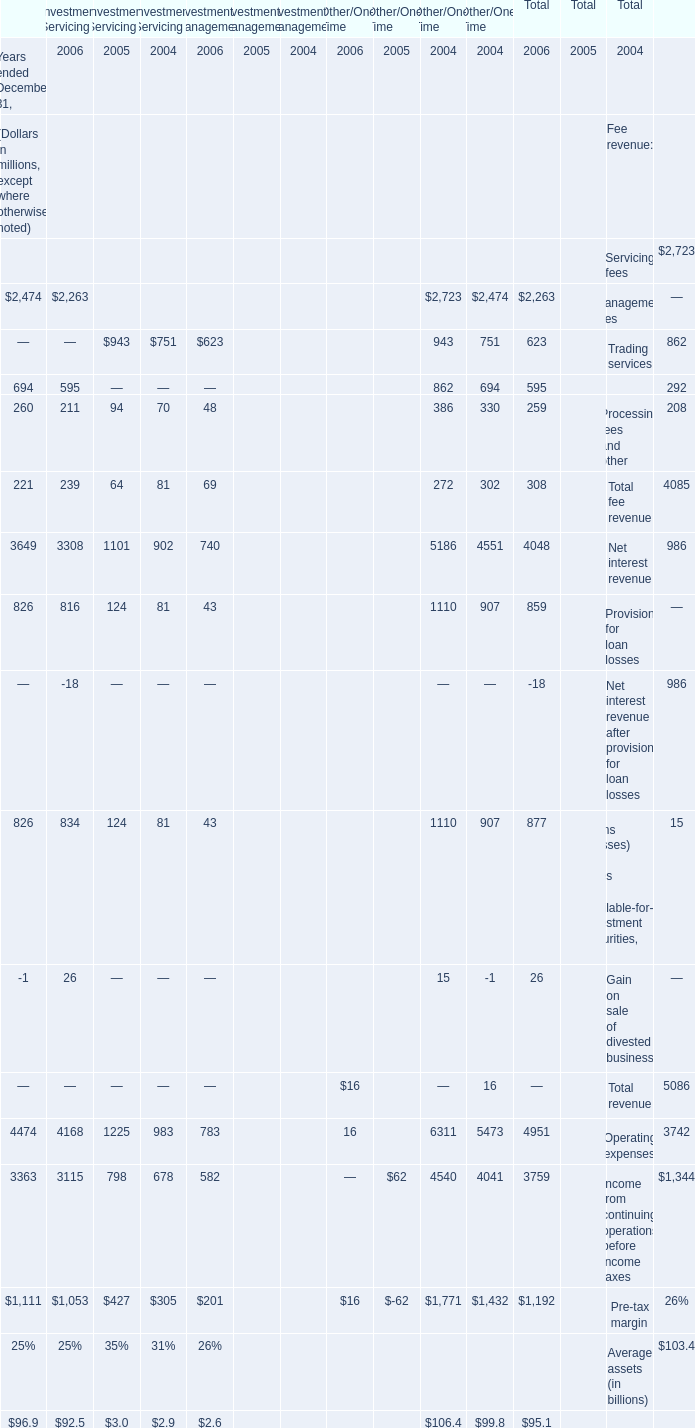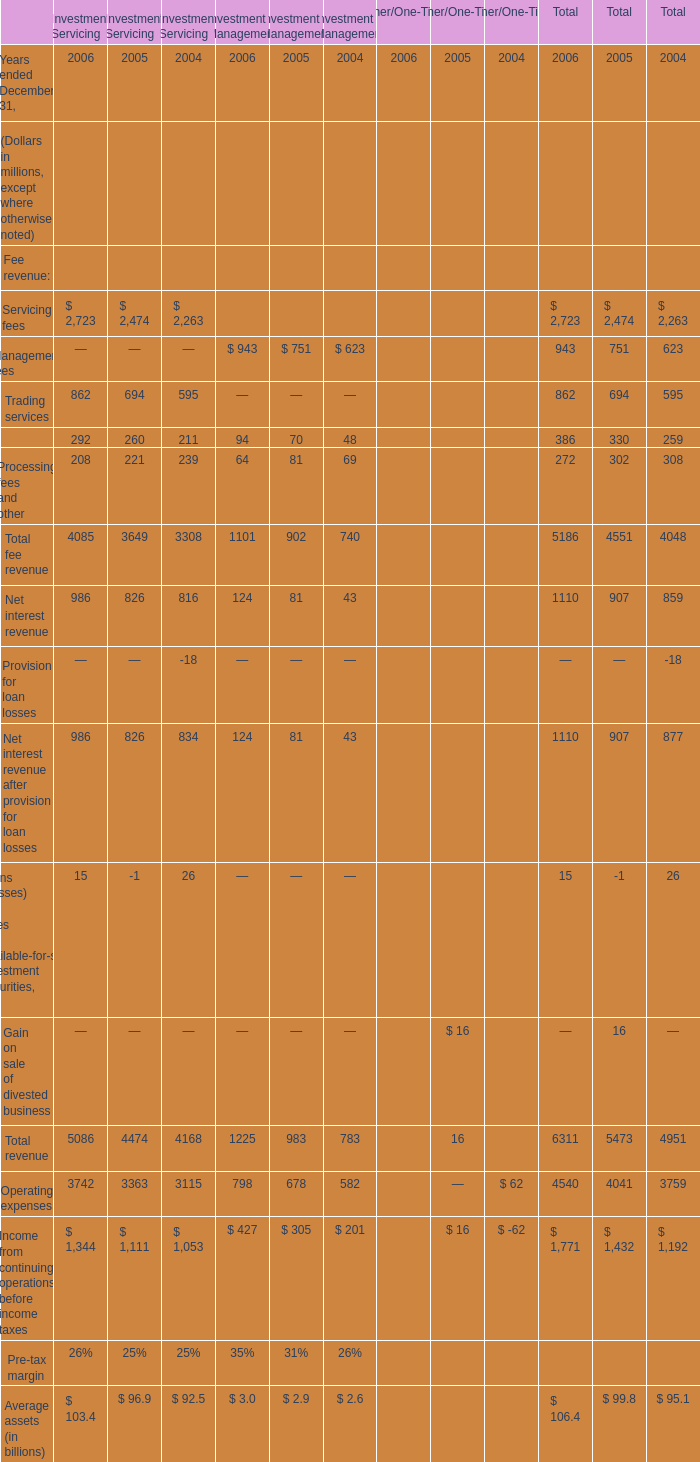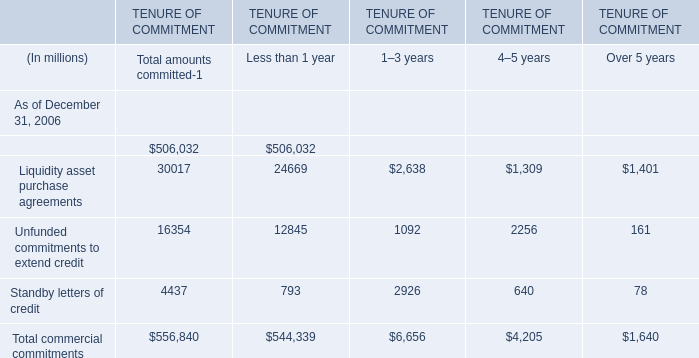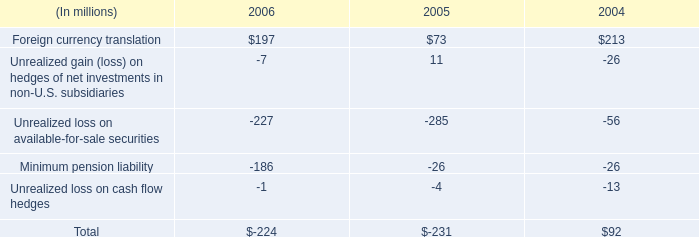What was the total amount of the total fee revenue for investment management in the years where Processing fees and other for investment management is greater than 80? (in million) 
Computations: ((751 + 70) + 81)
Answer: 902.0. 